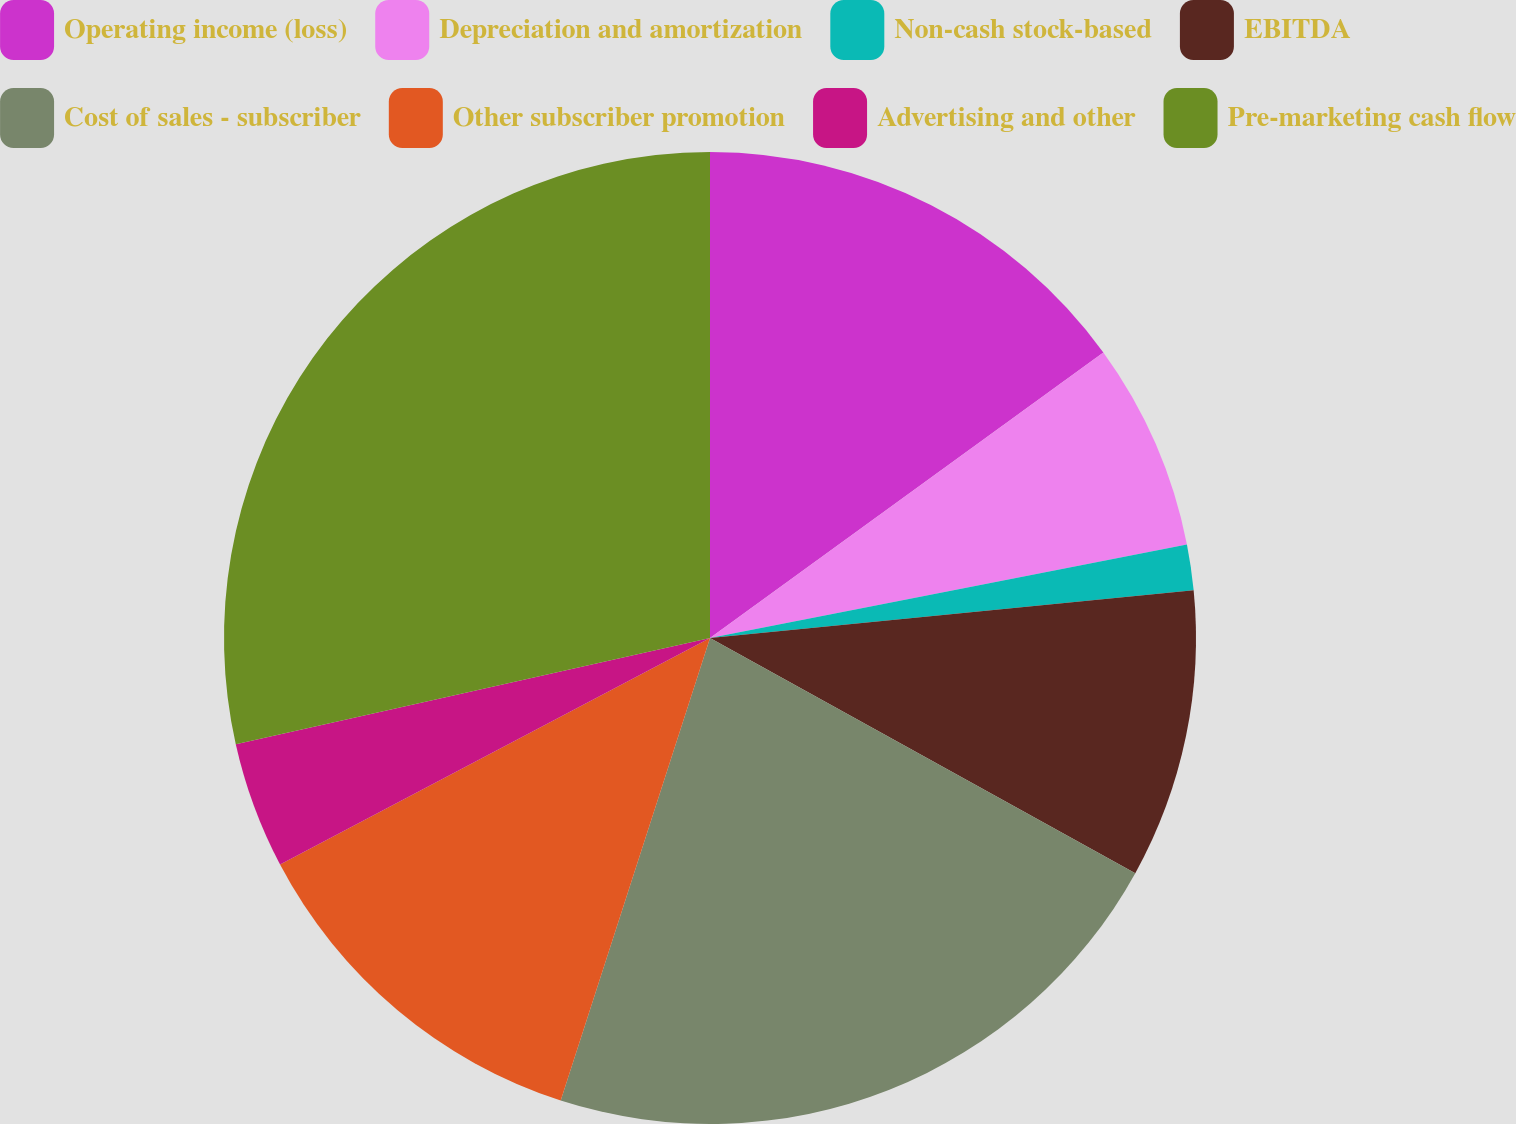Convert chart. <chart><loc_0><loc_0><loc_500><loc_500><pie_chart><fcel>Operating income (loss)<fcel>Depreciation and amortization<fcel>Non-cash stock-based<fcel>EBITDA<fcel>Cost of sales - subscriber<fcel>Other subscriber promotion<fcel>Advertising and other<fcel>Pre-marketing cash flow<nl><fcel>15.01%<fcel>6.91%<fcel>1.51%<fcel>9.61%<fcel>21.93%<fcel>12.31%<fcel>4.21%<fcel>28.51%<nl></chart> 